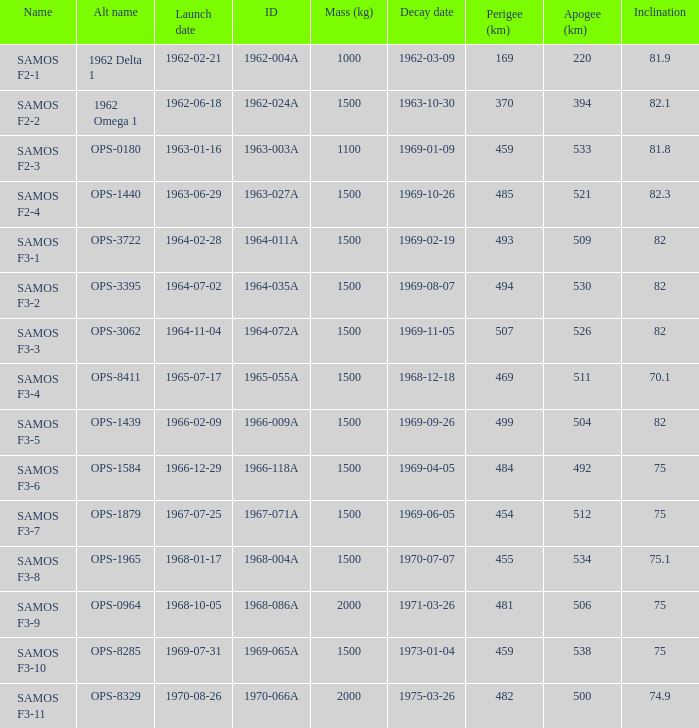What is the inclination when the alt name is OPS-1584? 75.0. 